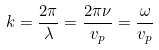<formula> <loc_0><loc_0><loc_500><loc_500>k = { \frac { 2 \pi } { \lambda } } = { \frac { 2 \pi \nu } { v _ { p } } } = { \frac { \omega } { v _ { p } } }</formula> 